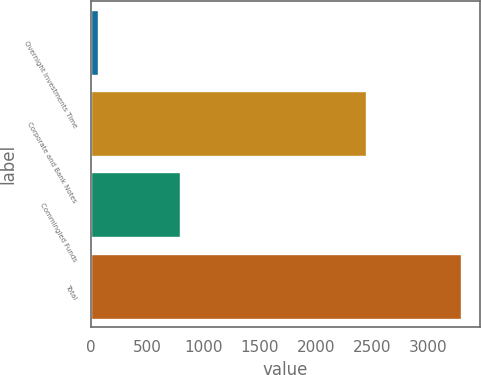Convert chart to OTSL. <chart><loc_0><loc_0><loc_500><loc_500><bar_chart><fcel>Overnight Investments Time<fcel>Corporate and Bank Notes<fcel>Commingled Funds<fcel>Total<nl><fcel>60<fcel>2441<fcel>789<fcel>3290<nl></chart> 